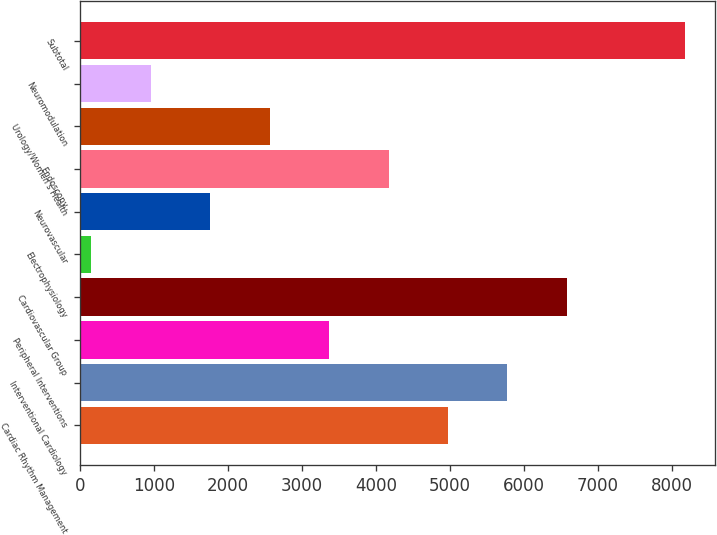Convert chart. <chart><loc_0><loc_0><loc_500><loc_500><bar_chart><fcel>Cardiac Rhythm Management<fcel>Interventional Cardiology<fcel>Peripheral Interventions<fcel>Cardiovascular Group<fcel>Electrophysiology<fcel>Neurovascular<fcel>Endoscopy<fcel>Urology/Women's Health<fcel>Neuromodulation<fcel>Subtotal<nl><fcel>4972.4<fcel>5776.3<fcel>3364.6<fcel>6580.2<fcel>149<fcel>1756.8<fcel>4168.5<fcel>2560.7<fcel>952.9<fcel>8177<nl></chart> 